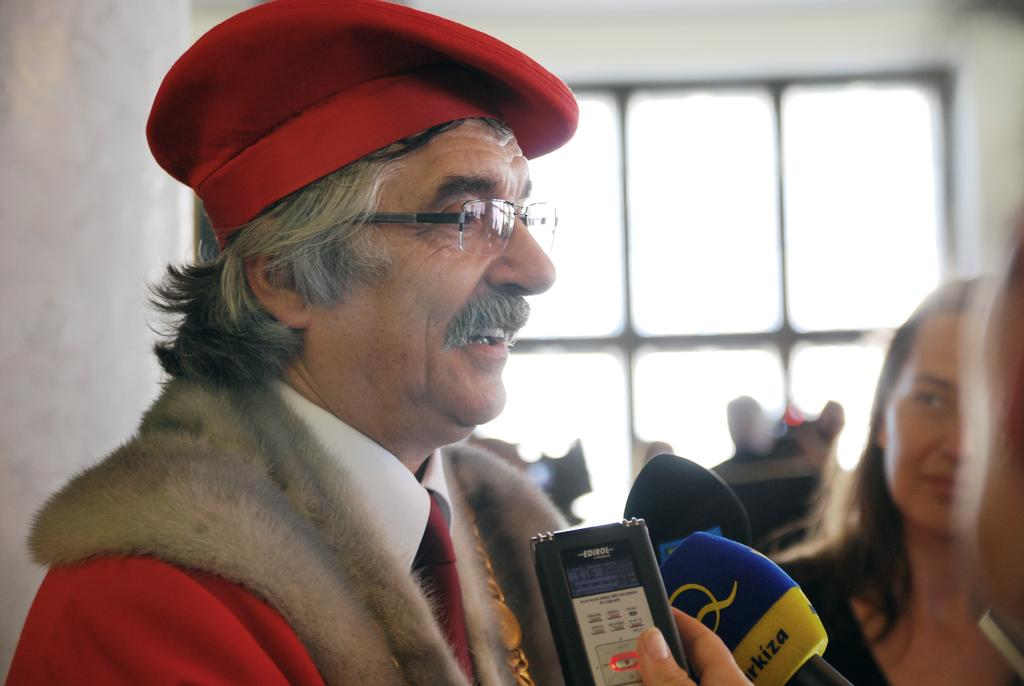What are the people in the image doing? There is a group of people on the floor in the image. What objects can be seen in the image? There are objects visible in the image. What device is present in the image that is used for amplifying sound? A microphone (mike) is present in the image. What can be seen in the background of the image? There is a wall and a glass window in the window in the background of the image. Where might this image have been taken? The image may have been taken in a hall. What type of mitten is being used by the deer in the image? There is no deer or mitten present in the image. 